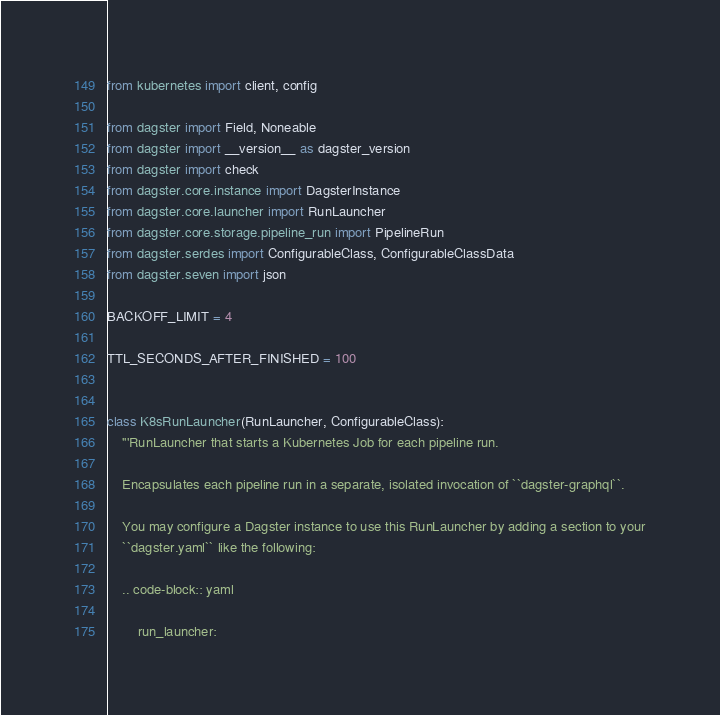<code> <loc_0><loc_0><loc_500><loc_500><_Python_>from kubernetes import client, config

from dagster import Field, Noneable
from dagster import __version__ as dagster_version
from dagster import check
from dagster.core.instance import DagsterInstance
from dagster.core.launcher import RunLauncher
from dagster.core.storage.pipeline_run import PipelineRun
from dagster.serdes import ConfigurableClass, ConfigurableClassData
from dagster.seven import json

BACKOFF_LIMIT = 4

TTL_SECONDS_AFTER_FINISHED = 100


class K8sRunLauncher(RunLauncher, ConfigurableClass):
    '''RunLauncher that starts a Kubernetes Job for each pipeline run.

    Encapsulates each pipeline run in a separate, isolated invocation of ``dagster-graphql``.

    You may configure a Dagster instance to use this RunLauncher by adding a section to your
    ``dagster.yaml`` like the following:

    .. code-block:: yaml

        run_launcher:</code> 